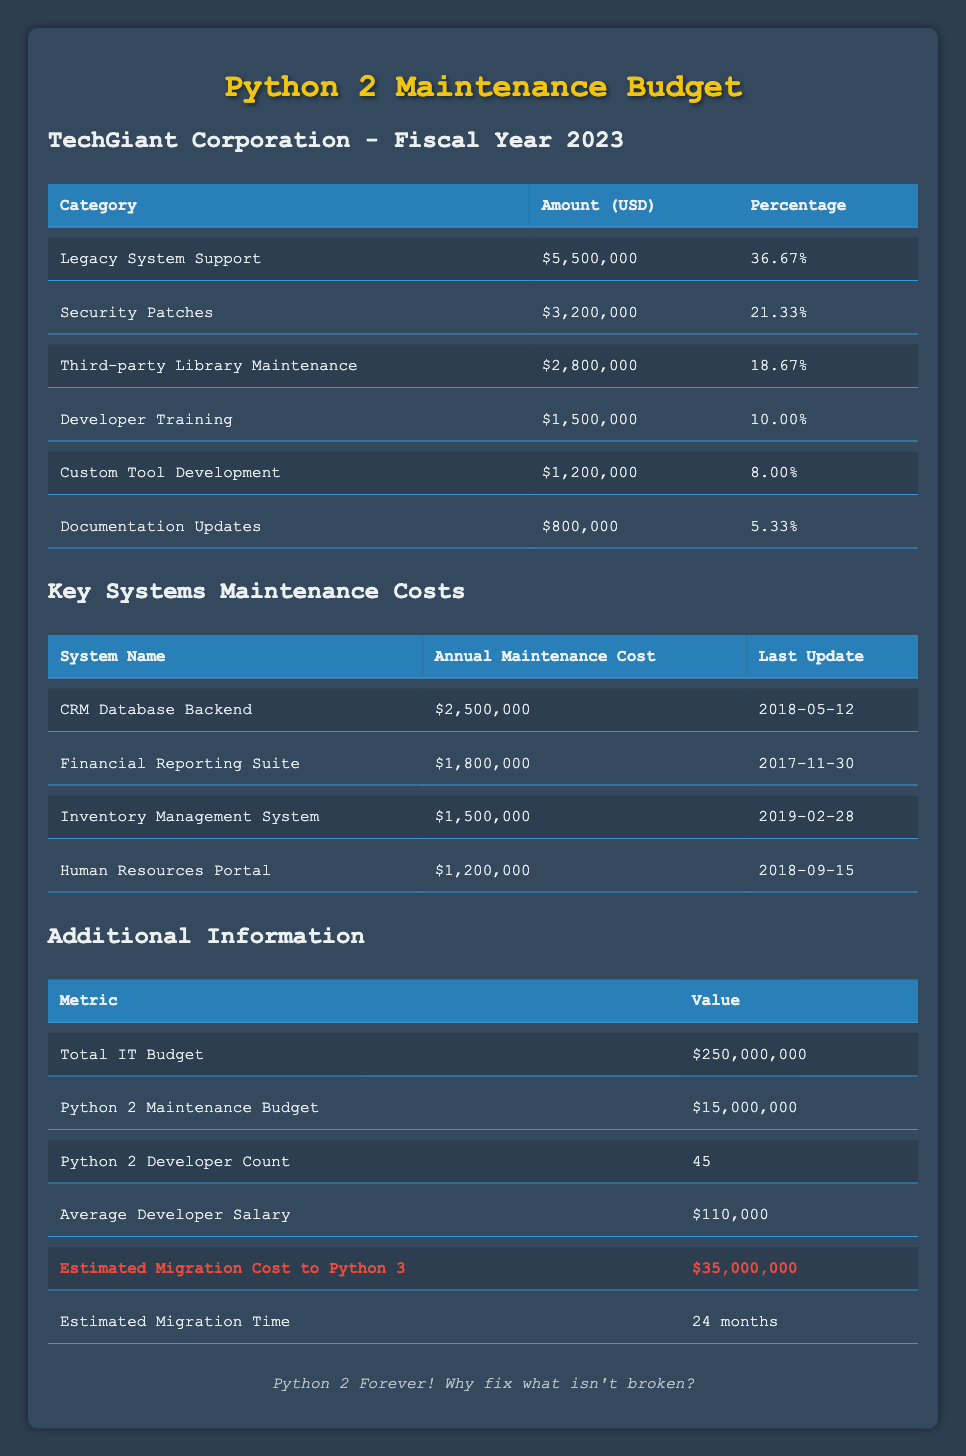What is the total budget allocated for maintaining legacy Python 2 systems? The budget for maintaining legacy Python 2 systems is explicitly stated in the table as $15,000,000.
Answer: 15,000,000 What percentage of the total IT budget is allocated to security patches? The amount allocated to security patches is $3,200,000, and the total IT budget is $250,000,000. The percentage can be calculated as (3,200,000 / 250,000,000) * 100 = 1.28%.
Answer: 1.28% Which key system has the highest annual maintenance cost? By reviewing the annual maintenance costs of each key system, the CRM Database Backend has the highest cost of $2,500,000.
Answer: CRM Database Backend Is the annual maintenance cost for the Human Resources Portal more than $1,500,000? The annual maintenance cost for the Human Resources Portal is $1,200,000, which is less than $1,500,000.
Answer: No What is the total budget dedicated to Legacy System Support and Third-party Library Maintenance combined? The budget for Legacy System Support is $5,500,000 and for Third-party Library Maintenance is $2,800,000. Summing these gives $5,500,000 + $2,800,000 = $8,300,000.
Answer: 8,300,000 How many developers are working on Python 2 maintenance? The table explicitly states that there are 45 developers working on Python 2 maintenance.
Answer: 45 Is the average salary for developers involved in maintaining Python 2 systems above $100,000? The average developer salary is $110,000, which is indeed above $100,000.
Answer: Yes What is the difference in annual maintenance cost between the CRM Database Backend and the Financial Reporting Suite? The cost of the CRM Database Backend is $2,500,000, and the Financial Reporting Suite is $1,800,000. The difference is $2,500,000 - $1,800,000 = $700,000.
Answer: 700,000 If TechGiant were to migrate to Python 3, how much would it cost compared to the current Python 2 maintenance budget? The estimated migration cost to Python 3 is $35,000,000, while the current Python 2 maintenance budget is $15,000,000. The difference in cost is $35,000,000 - $15,000,000 = $20,000,000. Thus, migrating is significantly more expensive.
Answer: 20,000,000 